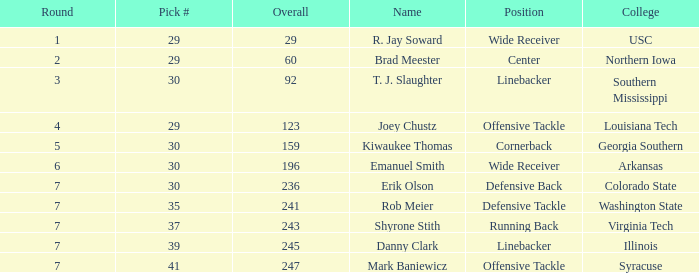What is the average Round for wide receiver r. jay soward and Overall smaller than 29? None. 